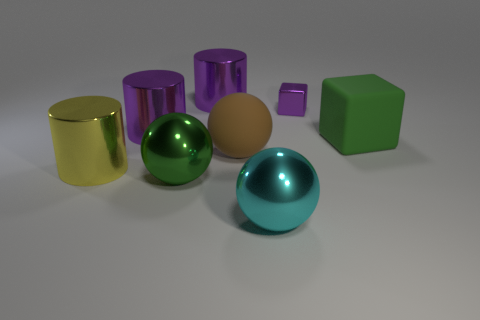What is the material of the large green sphere?
Keep it short and to the point. Metal. What number of purple cylinders are the same size as the cyan object?
Your answer should be very brief. 2. Are there the same number of large cubes that are in front of the cyan sphere and large rubber blocks on the left side of the brown matte ball?
Provide a short and direct response. Yes. Is the yellow object made of the same material as the green ball?
Offer a terse response. Yes. There is a big purple object that is behind the small purple metallic block; are there any big green objects that are on the left side of it?
Provide a short and direct response. Yes. Are there any big purple metallic objects that have the same shape as the tiny purple metallic object?
Make the answer very short. No. Do the tiny metallic thing and the big block have the same color?
Give a very brief answer. No. What is the material of the large green thing in front of the big rubber object to the left of the tiny metallic cube?
Make the answer very short. Metal. What size is the green shiny thing?
Provide a succinct answer. Large. What is the size of the brown thing that is the same material as the green cube?
Ensure brevity in your answer.  Large. 